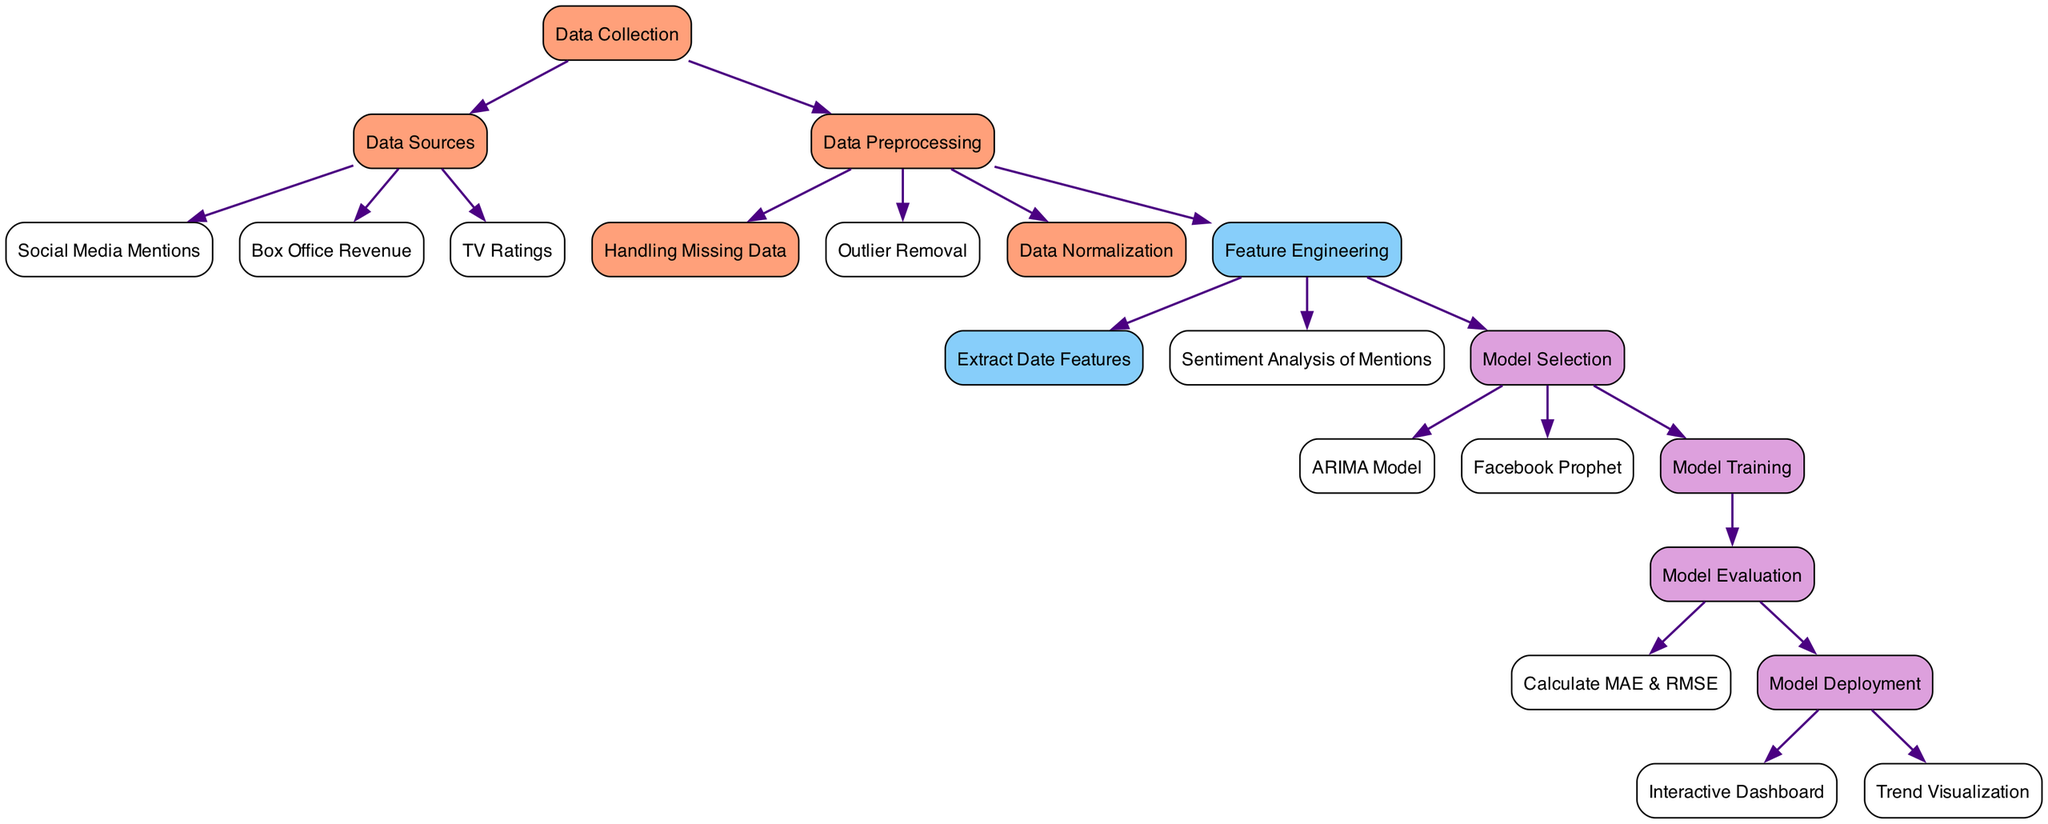How many nodes are present in the diagram? By counting the unique nodes listed in the diagram data, we find that there are 20 nodes representing different stages of the popularity trend analysis process.
Answer: 20 Which node comes after data preprocessing? Following the node "data preprocessing," the next nodes connected in sequence are "missing data handling," "outlier removal," "data normalization," and "feature engineering." Since the question asks for the immediate next step, the answer is "handling missing data."
Answer: Handling Missing Data What is the purpose of the sentiment analysis node? The "sentiment analysis" node is designed to assess the feelings and opinions expressed in social media mentions of Iren Krivoshieva, which is an essential aspect of evaluating popularity.
Answer: Assess feelings and opinions Which model is chosen after model selection? After the "model selection" node, two models are identified: "ARIMA" and "Facebook Prophet." Thus, any of these models can be chosen, but since there is no specification within the diagram about a preference, both can be considered valid responses.
Answer: ARIMA or Facebook Prophet What is the final outcome of the diagram's process? The arrows leading out from the "model deployment" node indicate that it can lead to either an "interactive dashboard" or "trend visualization," both of which represent the successful output of the model deployment phase.
Answer: Interactive Dashboard or Trend Visualization Which type of data sources are used for the analysis? The data sources incorporated in the diagram include "social media mentions," "box office revenue," and "tv ratings," which are indicated as the three main points of data collected for analyzing the popularity trend.
Answer: Social Media Mentions, Box Office Revenue, TV Ratings What forms of data preprocessing are highlighted in the diagram? The diagram specifies three key processes within data preprocessing: "handling missing data," "outlier removal," and "data normalization." These are essential tasks to ensure that the data is clean and suitable for analysis.
Answer: Handling Missing Data, Outlier Removal, Data Normalization What metrics are calculated to evaluate the model? The evaluation of the models is represented in the diagram by the "Calculate MAE & RMSE" node, which indicates that Mean Absolute Error and Root Mean Square Error are the metrics used for this evaluation.
Answer: MAE & RMSE What analysis is performed on social media mentions? The diagram indicates that "sentiment analysis" is performed on social media mentions, which means it focuses on the emotional content of the mentions to derive insights into popularity.
Answer: Sentiment Analysis 